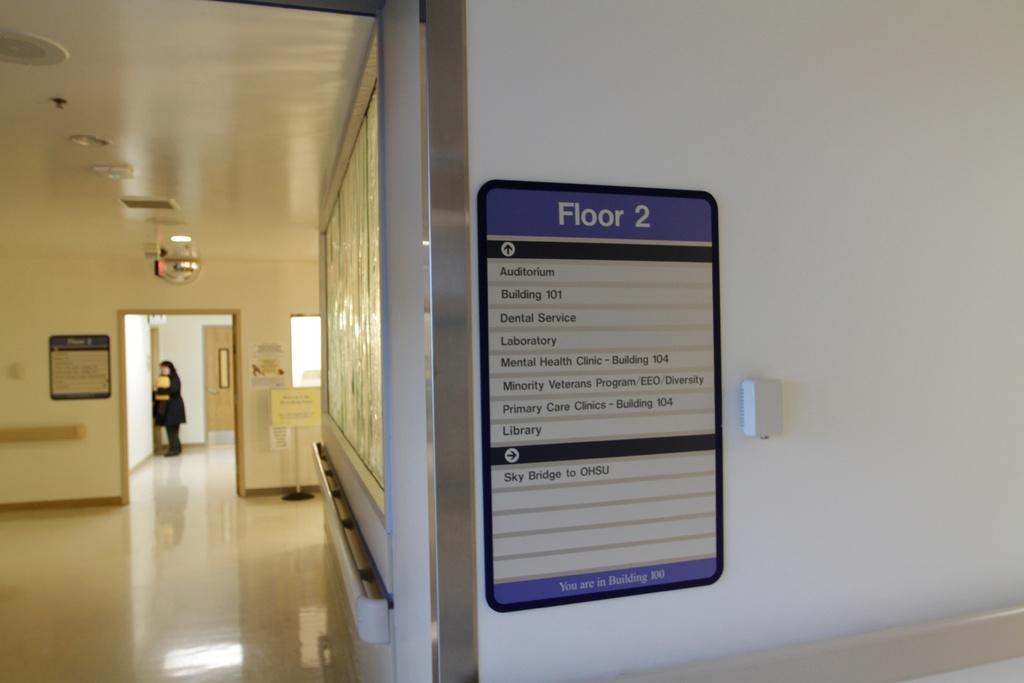Please provide a concise description of this image. In this picture we can see boards attached to the walls and a pole. There is a person standing on the floor and we can see posters and lights. 